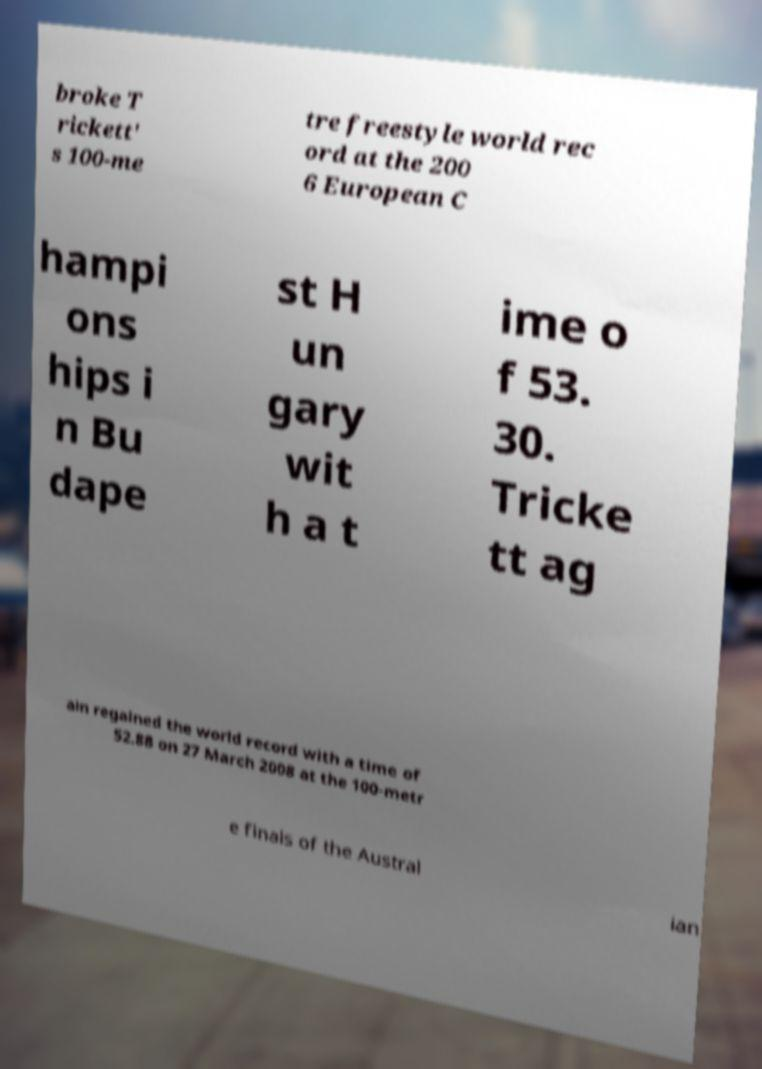I need the written content from this picture converted into text. Can you do that? broke T rickett' s 100-me tre freestyle world rec ord at the 200 6 European C hampi ons hips i n Bu dape st H un gary wit h a t ime o f 53. 30. Tricke tt ag ain regained the world record with a time of 52.88 on 27 March 2008 at the 100-metr e finals of the Austral ian 